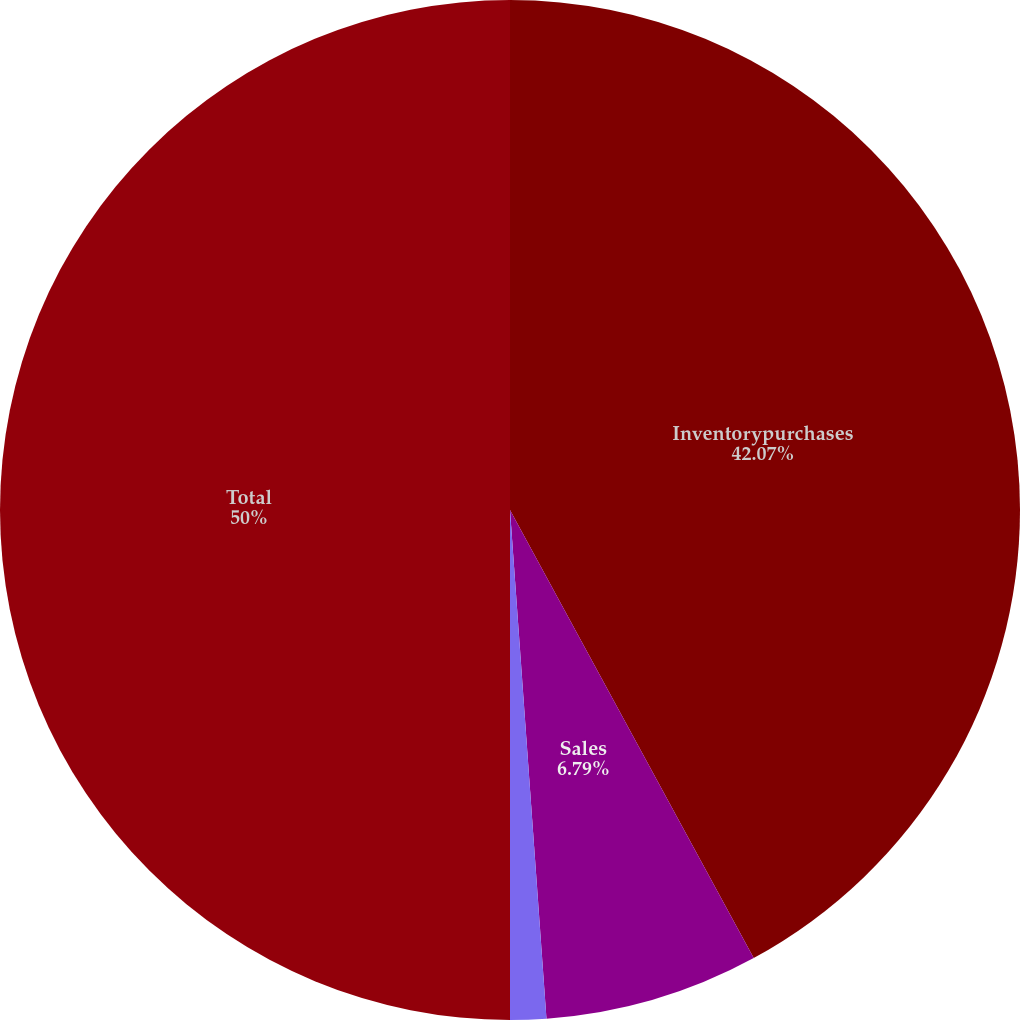Convert chart. <chart><loc_0><loc_0><loc_500><loc_500><pie_chart><fcel>Inventorypurchases<fcel>Sales<fcel>RoyaltiesandOther<fcel>Total<nl><fcel>42.07%<fcel>6.79%<fcel>1.14%<fcel>50.0%<nl></chart> 